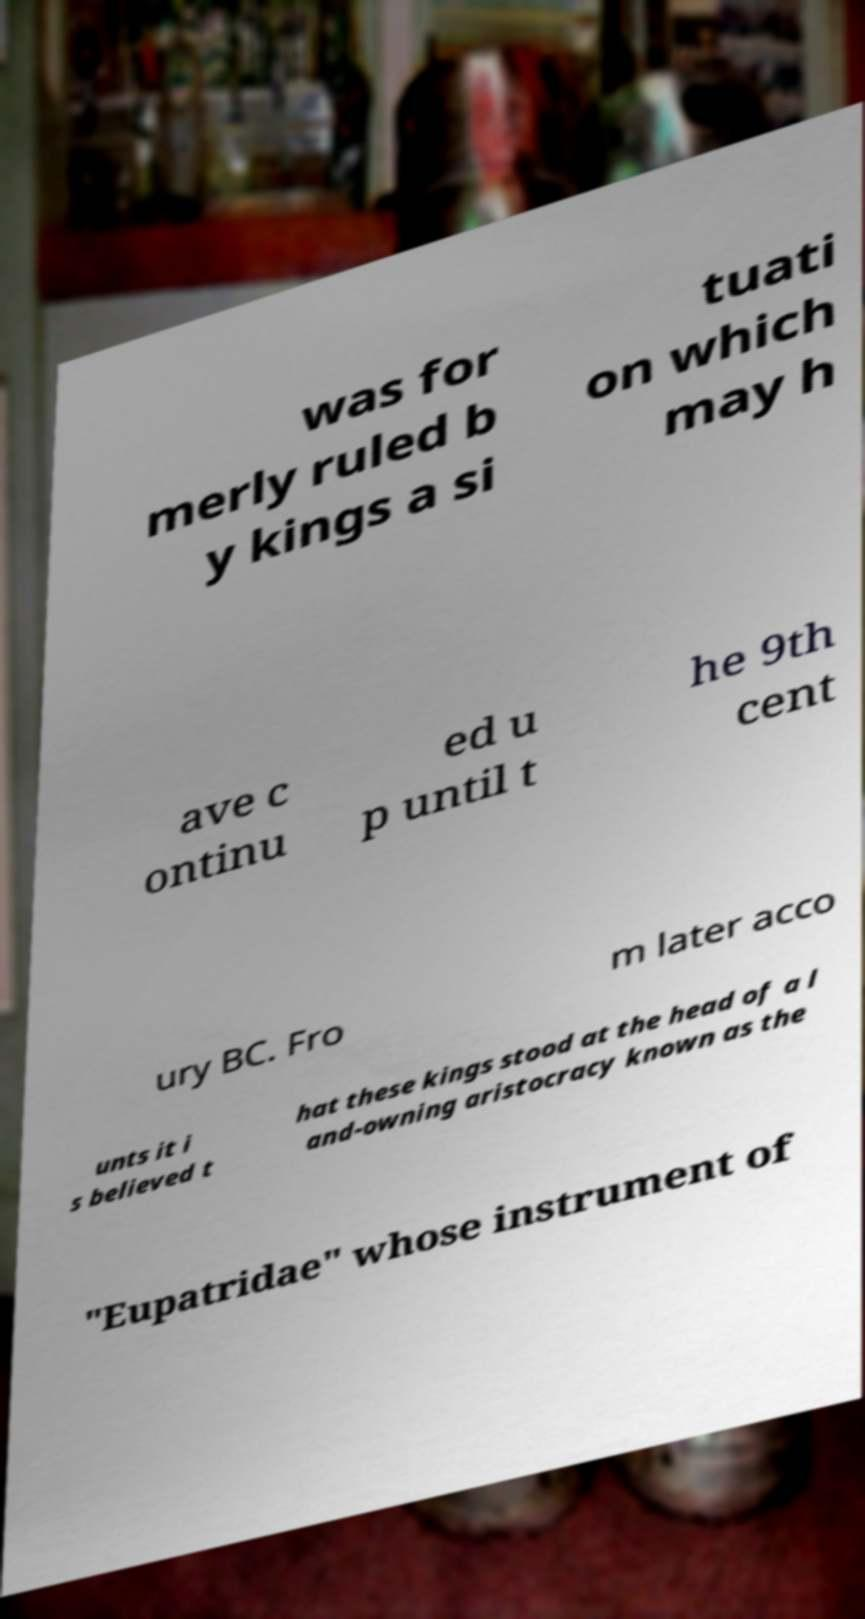There's text embedded in this image that I need extracted. Can you transcribe it verbatim? was for merly ruled b y kings a si tuati on which may h ave c ontinu ed u p until t he 9th cent ury BC. Fro m later acco unts it i s believed t hat these kings stood at the head of a l and-owning aristocracy known as the "Eupatridae" whose instrument of 